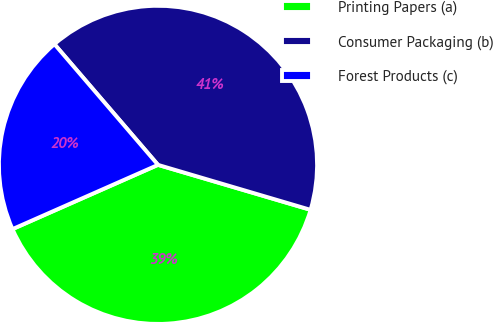Convert chart. <chart><loc_0><loc_0><loc_500><loc_500><pie_chart><fcel>Printing Papers (a)<fcel>Consumer Packaging (b)<fcel>Forest Products (c)<nl><fcel>38.82%<fcel>40.85%<fcel>20.33%<nl></chart> 